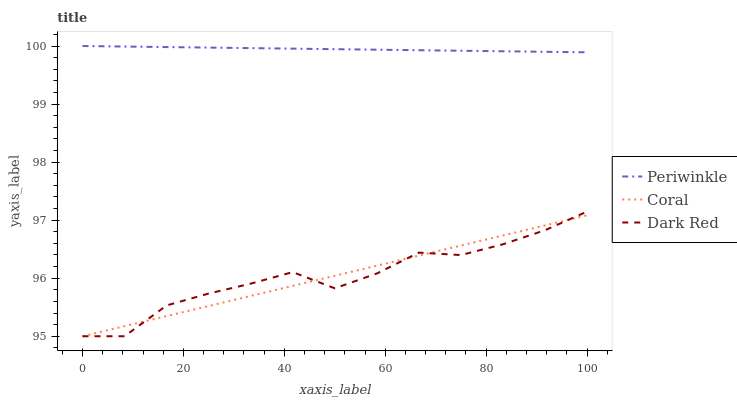Does Coral have the minimum area under the curve?
Answer yes or no. Yes. Does Periwinkle have the maximum area under the curve?
Answer yes or no. Yes. Does Periwinkle have the minimum area under the curve?
Answer yes or no. No. Does Coral have the maximum area under the curve?
Answer yes or no. No. Is Coral the smoothest?
Answer yes or no. Yes. Is Dark Red the roughest?
Answer yes or no. Yes. Is Periwinkle the smoothest?
Answer yes or no. No. Is Periwinkle the roughest?
Answer yes or no. No. Does Dark Red have the lowest value?
Answer yes or no. Yes. Does Periwinkle have the lowest value?
Answer yes or no. No. Does Periwinkle have the highest value?
Answer yes or no. Yes. Does Coral have the highest value?
Answer yes or no. No. Is Dark Red less than Periwinkle?
Answer yes or no. Yes. Is Periwinkle greater than Coral?
Answer yes or no. Yes. Does Coral intersect Dark Red?
Answer yes or no. Yes. Is Coral less than Dark Red?
Answer yes or no. No. Is Coral greater than Dark Red?
Answer yes or no. No. Does Dark Red intersect Periwinkle?
Answer yes or no. No. 